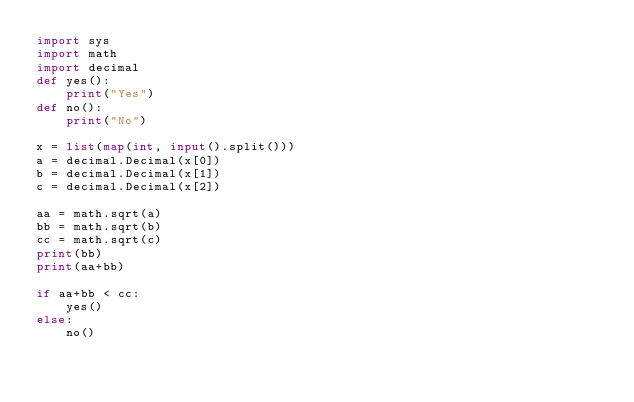<code> <loc_0><loc_0><loc_500><loc_500><_Python_>import sys
import math
import decimal
def yes():
    print("Yes")
def no():
    print("No")

x = list(map(int, input().split()))
a = decimal.Decimal(x[0])
b = decimal.Decimal(x[1])
c = decimal.Decimal(x[2])

aa = math.sqrt(a)
bb = math.sqrt(b)
cc = math.sqrt(c)
print(bb)
print(aa+bb)

if aa+bb < cc:
    yes()
else:
    no()
</code> 